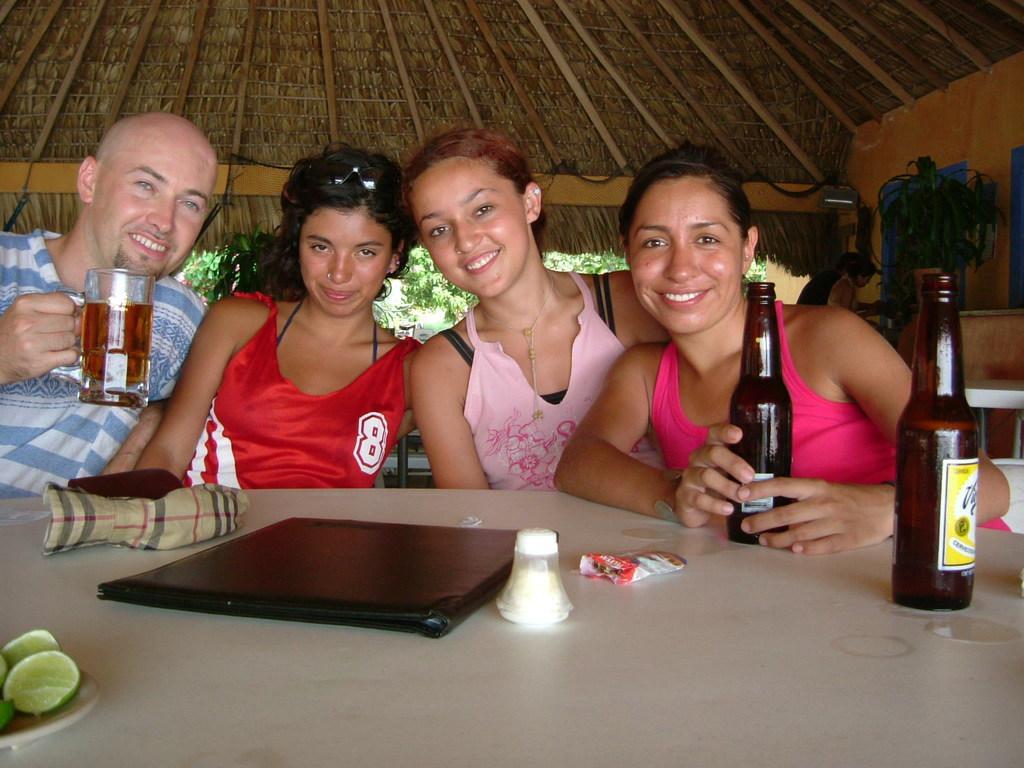Can you describe this image briefly? There are four members sitting in the chairs in front of the table on which a file, some bottles were placed. Three of them were women and one is man. In the background there is a roof of a hut. 